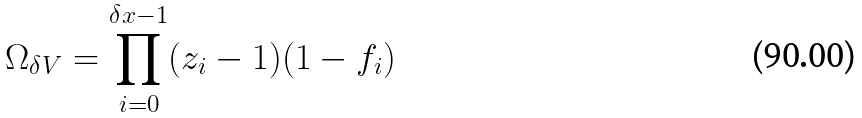Convert formula to latex. <formula><loc_0><loc_0><loc_500><loc_500>\Omega _ { \delta V } = \prod _ { i = 0 } ^ { \delta x - 1 } ( z _ { i } - 1 ) ( 1 - f _ { i } )</formula> 